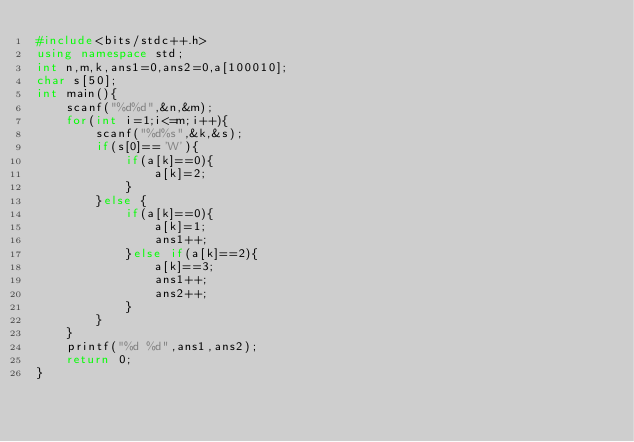<code> <loc_0><loc_0><loc_500><loc_500><_C++_>#include<bits/stdc++.h>
using namespace std;
int n,m,k,ans1=0,ans2=0,a[100010];
char s[50];
int main(){
	scanf("%d%d",&n,&m);
	for(int i=1;i<=m;i++){
		scanf("%d%s",&k,&s);
		if(s[0]=='W'){
			if(a[k]==0){
				a[k]=2;
			}
		}else {
			if(a[k]==0){
				a[k]=1;
				ans1++;
			}else if(a[k]==2){
				a[k]==3;
				ans1++;
				ans2++;
			}
		}
	}
	printf("%d %d",ans1,ans2);
	return 0;
}</code> 